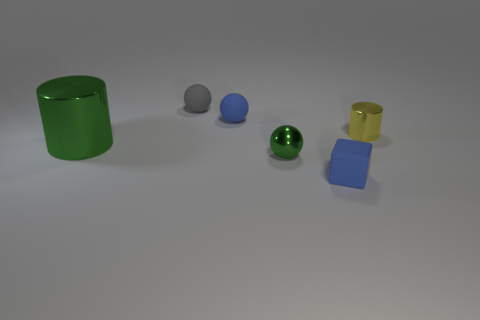Add 1 green metal spheres. How many objects exist? 7 Subtract all cylinders. How many objects are left? 4 Subtract 0 yellow spheres. How many objects are left? 6 Subtract all large brown rubber blocks. Subtract all rubber things. How many objects are left? 3 Add 2 metallic cylinders. How many metallic cylinders are left? 4 Add 6 green cylinders. How many green cylinders exist? 7 